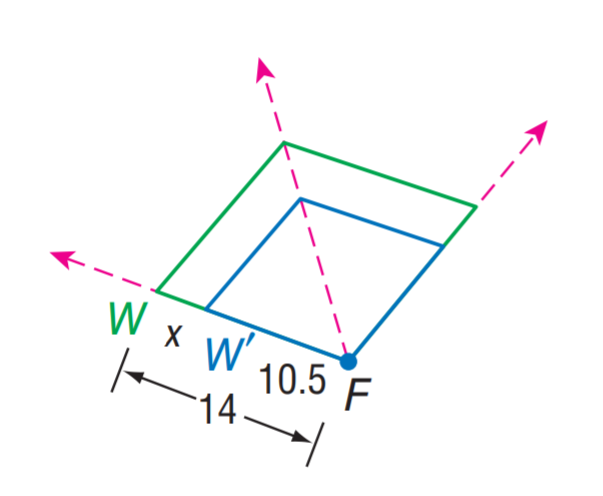Answer the mathemtical geometry problem and directly provide the correct option letter.
Question: Find the scale factor from W to W'.
Choices: A: 0.75 B: 1.25 C: 1.5 D: 1.75 A 